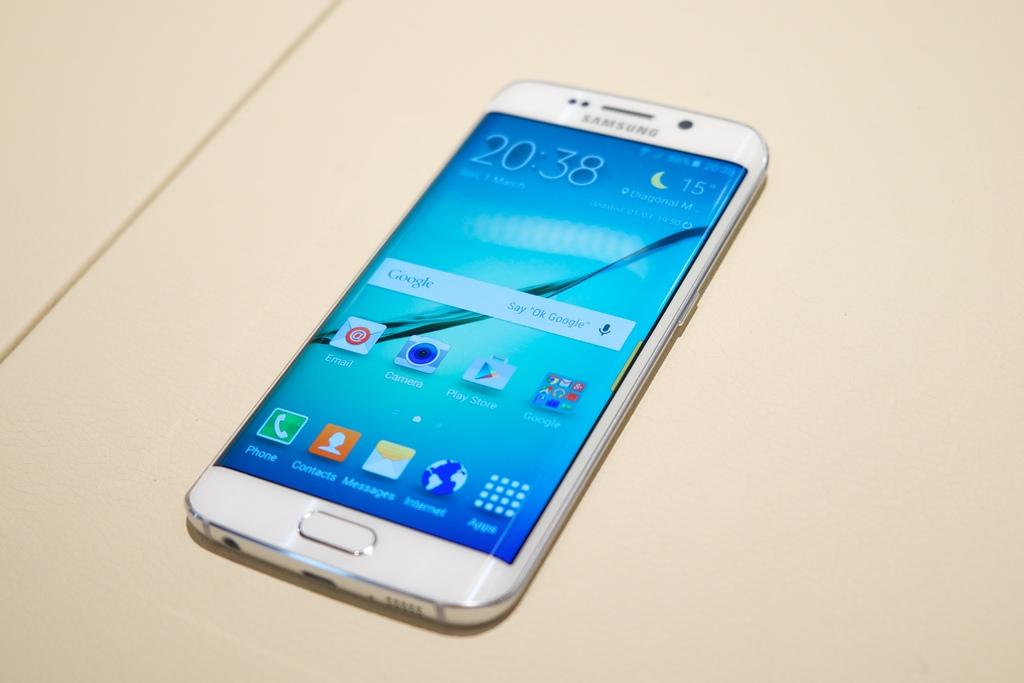What kind of phone is this?
Offer a terse response. Samsung. What is the time displayed on the phone?
Your response must be concise. 20:38. 